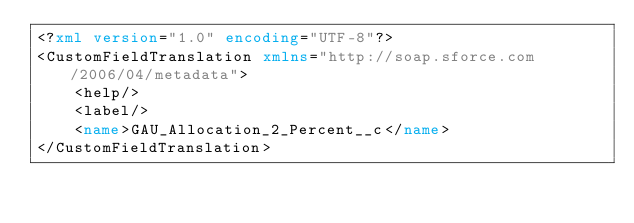<code> <loc_0><loc_0><loc_500><loc_500><_XML_><?xml version="1.0" encoding="UTF-8"?>
<CustomFieldTranslation xmlns="http://soap.sforce.com/2006/04/metadata">
    <help/>
    <label/>
    <name>GAU_Allocation_2_Percent__c</name>
</CustomFieldTranslation>
</code> 